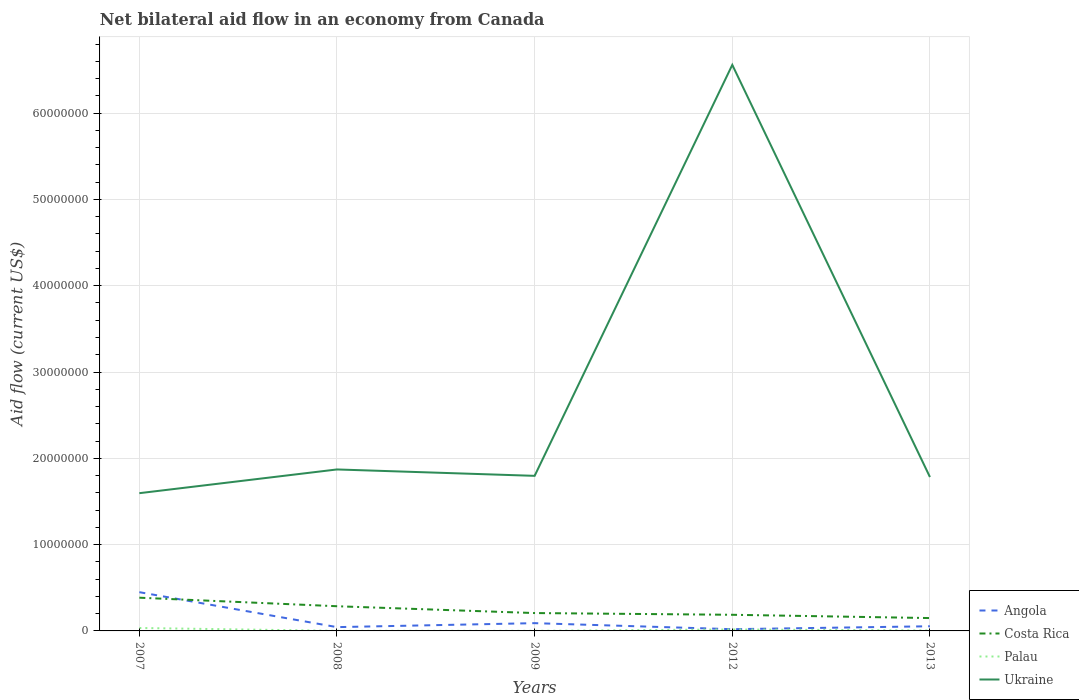Does the line corresponding to Costa Rica intersect with the line corresponding to Palau?
Provide a short and direct response. No. Is the number of lines equal to the number of legend labels?
Your answer should be compact. Yes. Across all years, what is the maximum net bilateral aid flow in Palau?
Your answer should be compact. 10000. What is the total net bilateral aid flow in Palau in the graph?
Provide a succinct answer. -1.60e+05. What is the difference between the highest and the second highest net bilateral aid flow in Palau?
Provide a short and direct response. 3.30e+05. Is the net bilateral aid flow in Ukraine strictly greater than the net bilateral aid flow in Costa Rica over the years?
Offer a very short reply. No. Are the values on the major ticks of Y-axis written in scientific E-notation?
Keep it short and to the point. No. Does the graph contain any zero values?
Your answer should be compact. No. Where does the legend appear in the graph?
Offer a very short reply. Bottom right. How many legend labels are there?
Your answer should be compact. 4. How are the legend labels stacked?
Your answer should be compact. Vertical. What is the title of the graph?
Make the answer very short. Net bilateral aid flow in an economy from Canada. What is the Aid flow (current US$) of Angola in 2007?
Your answer should be compact. 4.49e+06. What is the Aid flow (current US$) of Costa Rica in 2007?
Your response must be concise. 3.85e+06. What is the Aid flow (current US$) of Palau in 2007?
Make the answer very short. 3.40e+05. What is the Aid flow (current US$) of Ukraine in 2007?
Your answer should be very brief. 1.60e+07. What is the Aid flow (current US$) in Angola in 2008?
Your answer should be compact. 4.40e+05. What is the Aid flow (current US$) in Costa Rica in 2008?
Give a very brief answer. 2.86e+06. What is the Aid flow (current US$) in Ukraine in 2008?
Offer a terse response. 1.87e+07. What is the Aid flow (current US$) of Angola in 2009?
Ensure brevity in your answer.  9.00e+05. What is the Aid flow (current US$) of Costa Rica in 2009?
Make the answer very short. 2.07e+06. What is the Aid flow (current US$) in Ukraine in 2009?
Offer a terse response. 1.80e+07. What is the Aid flow (current US$) of Angola in 2012?
Provide a succinct answer. 2.00e+05. What is the Aid flow (current US$) in Costa Rica in 2012?
Keep it short and to the point. 1.87e+06. What is the Aid flow (current US$) in Palau in 2012?
Make the answer very short. 1.70e+05. What is the Aid flow (current US$) of Ukraine in 2012?
Your answer should be very brief. 6.56e+07. What is the Aid flow (current US$) of Angola in 2013?
Provide a succinct answer. 5.40e+05. What is the Aid flow (current US$) in Costa Rica in 2013?
Give a very brief answer. 1.49e+06. What is the Aid flow (current US$) of Palau in 2013?
Give a very brief answer. 5.00e+04. What is the Aid flow (current US$) in Ukraine in 2013?
Give a very brief answer. 1.78e+07. Across all years, what is the maximum Aid flow (current US$) of Angola?
Offer a very short reply. 4.49e+06. Across all years, what is the maximum Aid flow (current US$) of Costa Rica?
Make the answer very short. 3.85e+06. Across all years, what is the maximum Aid flow (current US$) in Ukraine?
Keep it short and to the point. 6.56e+07. Across all years, what is the minimum Aid flow (current US$) in Angola?
Provide a short and direct response. 2.00e+05. Across all years, what is the minimum Aid flow (current US$) of Costa Rica?
Provide a succinct answer. 1.49e+06. Across all years, what is the minimum Aid flow (current US$) in Palau?
Ensure brevity in your answer.  10000. Across all years, what is the minimum Aid flow (current US$) in Ukraine?
Offer a very short reply. 1.60e+07. What is the total Aid flow (current US$) of Angola in the graph?
Offer a terse response. 6.57e+06. What is the total Aid flow (current US$) of Costa Rica in the graph?
Your response must be concise. 1.21e+07. What is the total Aid flow (current US$) in Palau in the graph?
Your answer should be very brief. 5.80e+05. What is the total Aid flow (current US$) of Ukraine in the graph?
Provide a short and direct response. 1.36e+08. What is the difference between the Aid flow (current US$) in Angola in 2007 and that in 2008?
Make the answer very short. 4.05e+06. What is the difference between the Aid flow (current US$) in Costa Rica in 2007 and that in 2008?
Your answer should be very brief. 9.90e+05. What is the difference between the Aid flow (current US$) in Ukraine in 2007 and that in 2008?
Ensure brevity in your answer.  -2.75e+06. What is the difference between the Aid flow (current US$) in Angola in 2007 and that in 2009?
Give a very brief answer. 3.59e+06. What is the difference between the Aid flow (current US$) of Costa Rica in 2007 and that in 2009?
Keep it short and to the point. 1.78e+06. What is the difference between the Aid flow (current US$) in Ukraine in 2007 and that in 2009?
Your answer should be compact. -2.01e+06. What is the difference between the Aid flow (current US$) in Angola in 2007 and that in 2012?
Provide a succinct answer. 4.29e+06. What is the difference between the Aid flow (current US$) of Costa Rica in 2007 and that in 2012?
Your answer should be very brief. 1.98e+06. What is the difference between the Aid flow (current US$) of Ukraine in 2007 and that in 2012?
Make the answer very short. -4.96e+07. What is the difference between the Aid flow (current US$) in Angola in 2007 and that in 2013?
Your response must be concise. 3.95e+06. What is the difference between the Aid flow (current US$) of Costa Rica in 2007 and that in 2013?
Make the answer very short. 2.36e+06. What is the difference between the Aid flow (current US$) in Ukraine in 2007 and that in 2013?
Your response must be concise. -1.87e+06. What is the difference between the Aid flow (current US$) in Angola in 2008 and that in 2009?
Provide a succinct answer. -4.60e+05. What is the difference between the Aid flow (current US$) in Costa Rica in 2008 and that in 2009?
Keep it short and to the point. 7.90e+05. What is the difference between the Aid flow (current US$) of Palau in 2008 and that in 2009?
Ensure brevity in your answer.  0. What is the difference between the Aid flow (current US$) in Ukraine in 2008 and that in 2009?
Provide a succinct answer. 7.40e+05. What is the difference between the Aid flow (current US$) in Costa Rica in 2008 and that in 2012?
Ensure brevity in your answer.  9.90e+05. What is the difference between the Aid flow (current US$) in Palau in 2008 and that in 2012?
Make the answer very short. -1.60e+05. What is the difference between the Aid flow (current US$) of Ukraine in 2008 and that in 2012?
Your answer should be compact. -4.69e+07. What is the difference between the Aid flow (current US$) in Angola in 2008 and that in 2013?
Your response must be concise. -1.00e+05. What is the difference between the Aid flow (current US$) of Costa Rica in 2008 and that in 2013?
Offer a very short reply. 1.37e+06. What is the difference between the Aid flow (current US$) of Palau in 2008 and that in 2013?
Provide a short and direct response. -4.00e+04. What is the difference between the Aid flow (current US$) of Ukraine in 2008 and that in 2013?
Your answer should be very brief. 8.80e+05. What is the difference between the Aid flow (current US$) of Costa Rica in 2009 and that in 2012?
Provide a short and direct response. 2.00e+05. What is the difference between the Aid flow (current US$) of Ukraine in 2009 and that in 2012?
Provide a succinct answer. -4.76e+07. What is the difference between the Aid flow (current US$) in Angola in 2009 and that in 2013?
Your response must be concise. 3.60e+05. What is the difference between the Aid flow (current US$) of Costa Rica in 2009 and that in 2013?
Your response must be concise. 5.80e+05. What is the difference between the Aid flow (current US$) of Ukraine in 2009 and that in 2013?
Your response must be concise. 1.40e+05. What is the difference between the Aid flow (current US$) in Angola in 2012 and that in 2013?
Ensure brevity in your answer.  -3.40e+05. What is the difference between the Aid flow (current US$) of Ukraine in 2012 and that in 2013?
Offer a very short reply. 4.78e+07. What is the difference between the Aid flow (current US$) in Angola in 2007 and the Aid flow (current US$) in Costa Rica in 2008?
Keep it short and to the point. 1.63e+06. What is the difference between the Aid flow (current US$) of Angola in 2007 and the Aid flow (current US$) of Palau in 2008?
Offer a terse response. 4.48e+06. What is the difference between the Aid flow (current US$) in Angola in 2007 and the Aid flow (current US$) in Ukraine in 2008?
Your response must be concise. -1.42e+07. What is the difference between the Aid flow (current US$) in Costa Rica in 2007 and the Aid flow (current US$) in Palau in 2008?
Your answer should be compact. 3.84e+06. What is the difference between the Aid flow (current US$) of Costa Rica in 2007 and the Aid flow (current US$) of Ukraine in 2008?
Give a very brief answer. -1.49e+07. What is the difference between the Aid flow (current US$) of Palau in 2007 and the Aid flow (current US$) of Ukraine in 2008?
Offer a terse response. -1.84e+07. What is the difference between the Aid flow (current US$) of Angola in 2007 and the Aid flow (current US$) of Costa Rica in 2009?
Provide a succinct answer. 2.42e+06. What is the difference between the Aid flow (current US$) in Angola in 2007 and the Aid flow (current US$) in Palau in 2009?
Offer a terse response. 4.48e+06. What is the difference between the Aid flow (current US$) in Angola in 2007 and the Aid flow (current US$) in Ukraine in 2009?
Keep it short and to the point. -1.35e+07. What is the difference between the Aid flow (current US$) of Costa Rica in 2007 and the Aid flow (current US$) of Palau in 2009?
Keep it short and to the point. 3.84e+06. What is the difference between the Aid flow (current US$) of Costa Rica in 2007 and the Aid flow (current US$) of Ukraine in 2009?
Provide a succinct answer. -1.41e+07. What is the difference between the Aid flow (current US$) in Palau in 2007 and the Aid flow (current US$) in Ukraine in 2009?
Give a very brief answer. -1.76e+07. What is the difference between the Aid flow (current US$) of Angola in 2007 and the Aid flow (current US$) of Costa Rica in 2012?
Give a very brief answer. 2.62e+06. What is the difference between the Aid flow (current US$) in Angola in 2007 and the Aid flow (current US$) in Palau in 2012?
Make the answer very short. 4.32e+06. What is the difference between the Aid flow (current US$) of Angola in 2007 and the Aid flow (current US$) of Ukraine in 2012?
Keep it short and to the point. -6.11e+07. What is the difference between the Aid flow (current US$) in Costa Rica in 2007 and the Aid flow (current US$) in Palau in 2012?
Offer a terse response. 3.68e+06. What is the difference between the Aid flow (current US$) of Costa Rica in 2007 and the Aid flow (current US$) of Ukraine in 2012?
Keep it short and to the point. -6.17e+07. What is the difference between the Aid flow (current US$) of Palau in 2007 and the Aid flow (current US$) of Ukraine in 2012?
Make the answer very short. -6.52e+07. What is the difference between the Aid flow (current US$) of Angola in 2007 and the Aid flow (current US$) of Costa Rica in 2013?
Your response must be concise. 3.00e+06. What is the difference between the Aid flow (current US$) in Angola in 2007 and the Aid flow (current US$) in Palau in 2013?
Offer a very short reply. 4.44e+06. What is the difference between the Aid flow (current US$) of Angola in 2007 and the Aid flow (current US$) of Ukraine in 2013?
Offer a very short reply. -1.33e+07. What is the difference between the Aid flow (current US$) in Costa Rica in 2007 and the Aid flow (current US$) in Palau in 2013?
Your answer should be compact. 3.80e+06. What is the difference between the Aid flow (current US$) of Costa Rica in 2007 and the Aid flow (current US$) of Ukraine in 2013?
Provide a succinct answer. -1.40e+07. What is the difference between the Aid flow (current US$) of Palau in 2007 and the Aid flow (current US$) of Ukraine in 2013?
Your response must be concise. -1.75e+07. What is the difference between the Aid flow (current US$) of Angola in 2008 and the Aid flow (current US$) of Costa Rica in 2009?
Offer a very short reply. -1.63e+06. What is the difference between the Aid flow (current US$) of Angola in 2008 and the Aid flow (current US$) of Palau in 2009?
Offer a terse response. 4.30e+05. What is the difference between the Aid flow (current US$) in Angola in 2008 and the Aid flow (current US$) in Ukraine in 2009?
Offer a terse response. -1.75e+07. What is the difference between the Aid flow (current US$) in Costa Rica in 2008 and the Aid flow (current US$) in Palau in 2009?
Ensure brevity in your answer.  2.85e+06. What is the difference between the Aid flow (current US$) in Costa Rica in 2008 and the Aid flow (current US$) in Ukraine in 2009?
Your answer should be compact. -1.51e+07. What is the difference between the Aid flow (current US$) of Palau in 2008 and the Aid flow (current US$) of Ukraine in 2009?
Your answer should be very brief. -1.80e+07. What is the difference between the Aid flow (current US$) of Angola in 2008 and the Aid flow (current US$) of Costa Rica in 2012?
Provide a short and direct response. -1.43e+06. What is the difference between the Aid flow (current US$) of Angola in 2008 and the Aid flow (current US$) of Palau in 2012?
Keep it short and to the point. 2.70e+05. What is the difference between the Aid flow (current US$) of Angola in 2008 and the Aid flow (current US$) of Ukraine in 2012?
Keep it short and to the point. -6.52e+07. What is the difference between the Aid flow (current US$) of Costa Rica in 2008 and the Aid flow (current US$) of Palau in 2012?
Ensure brevity in your answer.  2.69e+06. What is the difference between the Aid flow (current US$) in Costa Rica in 2008 and the Aid flow (current US$) in Ukraine in 2012?
Your response must be concise. -6.27e+07. What is the difference between the Aid flow (current US$) in Palau in 2008 and the Aid flow (current US$) in Ukraine in 2012?
Provide a short and direct response. -6.56e+07. What is the difference between the Aid flow (current US$) in Angola in 2008 and the Aid flow (current US$) in Costa Rica in 2013?
Offer a terse response. -1.05e+06. What is the difference between the Aid flow (current US$) of Angola in 2008 and the Aid flow (current US$) of Ukraine in 2013?
Your response must be concise. -1.74e+07. What is the difference between the Aid flow (current US$) in Costa Rica in 2008 and the Aid flow (current US$) in Palau in 2013?
Your answer should be compact. 2.81e+06. What is the difference between the Aid flow (current US$) of Costa Rica in 2008 and the Aid flow (current US$) of Ukraine in 2013?
Provide a short and direct response. -1.50e+07. What is the difference between the Aid flow (current US$) of Palau in 2008 and the Aid flow (current US$) of Ukraine in 2013?
Your response must be concise. -1.78e+07. What is the difference between the Aid flow (current US$) of Angola in 2009 and the Aid flow (current US$) of Costa Rica in 2012?
Provide a short and direct response. -9.70e+05. What is the difference between the Aid flow (current US$) in Angola in 2009 and the Aid flow (current US$) in Palau in 2012?
Ensure brevity in your answer.  7.30e+05. What is the difference between the Aid flow (current US$) in Angola in 2009 and the Aid flow (current US$) in Ukraine in 2012?
Offer a terse response. -6.47e+07. What is the difference between the Aid flow (current US$) of Costa Rica in 2009 and the Aid flow (current US$) of Palau in 2012?
Offer a very short reply. 1.90e+06. What is the difference between the Aid flow (current US$) of Costa Rica in 2009 and the Aid flow (current US$) of Ukraine in 2012?
Your answer should be compact. -6.35e+07. What is the difference between the Aid flow (current US$) of Palau in 2009 and the Aid flow (current US$) of Ukraine in 2012?
Give a very brief answer. -6.56e+07. What is the difference between the Aid flow (current US$) of Angola in 2009 and the Aid flow (current US$) of Costa Rica in 2013?
Make the answer very short. -5.90e+05. What is the difference between the Aid flow (current US$) in Angola in 2009 and the Aid flow (current US$) in Palau in 2013?
Provide a short and direct response. 8.50e+05. What is the difference between the Aid flow (current US$) of Angola in 2009 and the Aid flow (current US$) of Ukraine in 2013?
Your answer should be very brief. -1.69e+07. What is the difference between the Aid flow (current US$) in Costa Rica in 2009 and the Aid flow (current US$) in Palau in 2013?
Your answer should be compact. 2.02e+06. What is the difference between the Aid flow (current US$) of Costa Rica in 2009 and the Aid flow (current US$) of Ukraine in 2013?
Keep it short and to the point. -1.58e+07. What is the difference between the Aid flow (current US$) in Palau in 2009 and the Aid flow (current US$) in Ukraine in 2013?
Provide a succinct answer. -1.78e+07. What is the difference between the Aid flow (current US$) in Angola in 2012 and the Aid flow (current US$) in Costa Rica in 2013?
Your answer should be very brief. -1.29e+06. What is the difference between the Aid flow (current US$) of Angola in 2012 and the Aid flow (current US$) of Palau in 2013?
Your response must be concise. 1.50e+05. What is the difference between the Aid flow (current US$) of Angola in 2012 and the Aid flow (current US$) of Ukraine in 2013?
Your answer should be compact. -1.76e+07. What is the difference between the Aid flow (current US$) of Costa Rica in 2012 and the Aid flow (current US$) of Palau in 2013?
Offer a terse response. 1.82e+06. What is the difference between the Aid flow (current US$) of Costa Rica in 2012 and the Aid flow (current US$) of Ukraine in 2013?
Ensure brevity in your answer.  -1.60e+07. What is the difference between the Aid flow (current US$) in Palau in 2012 and the Aid flow (current US$) in Ukraine in 2013?
Provide a short and direct response. -1.77e+07. What is the average Aid flow (current US$) in Angola per year?
Make the answer very short. 1.31e+06. What is the average Aid flow (current US$) of Costa Rica per year?
Make the answer very short. 2.43e+06. What is the average Aid flow (current US$) of Palau per year?
Keep it short and to the point. 1.16e+05. What is the average Aid flow (current US$) in Ukraine per year?
Your response must be concise. 2.72e+07. In the year 2007, what is the difference between the Aid flow (current US$) of Angola and Aid flow (current US$) of Costa Rica?
Make the answer very short. 6.40e+05. In the year 2007, what is the difference between the Aid flow (current US$) of Angola and Aid flow (current US$) of Palau?
Offer a terse response. 4.15e+06. In the year 2007, what is the difference between the Aid flow (current US$) in Angola and Aid flow (current US$) in Ukraine?
Provide a succinct answer. -1.15e+07. In the year 2007, what is the difference between the Aid flow (current US$) of Costa Rica and Aid flow (current US$) of Palau?
Ensure brevity in your answer.  3.51e+06. In the year 2007, what is the difference between the Aid flow (current US$) of Costa Rica and Aid flow (current US$) of Ukraine?
Your response must be concise. -1.21e+07. In the year 2007, what is the difference between the Aid flow (current US$) of Palau and Aid flow (current US$) of Ukraine?
Your response must be concise. -1.56e+07. In the year 2008, what is the difference between the Aid flow (current US$) in Angola and Aid flow (current US$) in Costa Rica?
Give a very brief answer. -2.42e+06. In the year 2008, what is the difference between the Aid flow (current US$) in Angola and Aid flow (current US$) in Ukraine?
Your response must be concise. -1.83e+07. In the year 2008, what is the difference between the Aid flow (current US$) in Costa Rica and Aid flow (current US$) in Palau?
Provide a short and direct response. 2.85e+06. In the year 2008, what is the difference between the Aid flow (current US$) in Costa Rica and Aid flow (current US$) in Ukraine?
Ensure brevity in your answer.  -1.58e+07. In the year 2008, what is the difference between the Aid flow (current US$) in Palau and Aid flow (current US$) in Ukraine?
Ensure brevity in your answer.  -1.87e+07. In the year 2009, what is the difference between the Aid flow (current US$) of Angola and Aid flow (current US$) of Costa Rica?
Keep it short and to the point. -1.17e+06. In the year 2009, what is the difference between the Aid flow (current US$) in Angola and Aid flow (current US$) in Palau?
Keep it short and to the point. 8.90e+05. In the year 2009, what is the difference between the Aid flow (current US$) in Angola and Aid flow (current US$) in Ukraine?
Provide a short and direct response. -1.71e+07. In the year 2009, what is the difference between the Aid flow (current US$) in Costa Rica and Aid flow (current US$) in Palau?
Keep it short and to the point. 2.06e+06. In the year 2009, what is the difference between the Aid flow (current US$) in Costa Rica and Aid flow (current US$) in Ukraine?
Provide a short and direct response. -1.59e+07. In the year 2009, what is the difference between the Aid flow (current US$) in Palau and Aid flow (current US$) in Ukraine?
Offer a terse response. -1.80e+07. In the year 2012, what is the difference between the Aid flow (current US$) of Angola and Aid flow (current US$) of Costa Rica?
Your response must be concise. -1.67e+06. In the year 2012, what is the difference between the Aid flow (current US$) in Angola and Aid flow (current US$) in Palau?
Your answer should be compact. 3.00e+04. In the year 2012, what is the difference between the Aid flow (current US$) of Angola and Aid flow (current US$) of Ukraine?
Provide a short and direct response. -6.54e+07. In the year 2012, what is the difference between the Aid flow (current US$) in Costa Rica and Aid flow (current US$) in Palau?
Your answer should be compact. 1.70e+06. In the year 2012, what is the difference between the Aid flow (current US$) in Costa Rica and Aid flow (current US$) in Ukraine?
Offer a very short reply. -6.37e+07. In the year 2012, what is the difference between the Aid flow (current US$) of Palau and Aid flow (current US$) of Ukraine?
Keep it short and to the point. -6.54e+07. In the year 2013, what is the difference between the Aid flow (current US$) in Angola and Aid flow (current US$) in Costa Rica?
Ensure brevity in your answer.  -9.50e+05. In the year 2013, what is the difference between the Aid flow (current US$) in Angola and Aid flow (current US$) in Palau?
Keep it short and to the point. 4.90e+05. In the year 2013, what is the difference between the Aid flow (current US$) in Angola and Aid flow (current US$) in Ukraine?
Provide a succinct answer. -1.73e+07. In the year 2013, what is the difference between the Aid flow (current US$) in Costa Rica and Aid flow (current US$) in Palau?
Make the answer very short. 1.44e+06. In the year 2013, what is the difference between the Aid flow (current US$) in Costa Rica and Aid flow (current US$) in Ukraine?
Keep it short and to the point. -1.63e+07. In the year 2013, what is the difference between the Aid flow (current US$) in Palau and Aid flow (current US$) in Ukraine?
Your answer should be very brief. -1.78e+07. What is the ratio of the Aid flow (current US$) of Angola in 2007 to that in 2008?
Give a very brief answer. 10.2. What is the ratio of the Aid flow (current US$) in Costa Rica in 2007 to that in 2008?
Give a very brief answer. 1.35. What is the ratio of the Aid flow (current US$) in Palau in 2007 to that in 2008?
Offer a very short reply. 34. What is the ratio of the Aid flow (current US$) in Ukraine in 2007 to that in 2008?
Offer a very short reply. 0.85. What is the ratio of the Aid flow (current US$) of Angola in 2007 to that in 2009?
Your answer should be very brief. 4.99. What is the ratio of the Aid flow (current US$) of Costa Rica in 2007 to that in 2009?
Your answer should be very brief. 1.86. What is the ratio of the Aid flow (current US$) of Palau in 2007 to that in 2009?
Your answer should be compact. 34. What is the ratio of the Aid flow (current US$) in Ukraine in 2007 to that in 2009?
Your answer should be compact. 0.89. What is the ratio of the Aid flow (current US$) of Angola in 2007 to that in 2012?
Offer a terse response. 22.45. What is the ratio of the Aid flow (current US$) of Costa Rica in 2007 to that in 2012?
Give a very brief answer. 2.06. What is the ratio of the Aid flow (current US$) in Ukraine in 2007 to that in 2012?
Your response must be concise. 0.24. What is the ratio of the Aid flow (current US$) of Angola in 2007 to that in 2013?
Your answer should be very brief. 8.31. What is the ratio of the Aid flow (current US$) in Costa Rica in 2007 to that in 2013?
Provide a succinct answer. 2.58. What is the ratio of the Aid flow (current US$) in Ukraine in 2007 to that in 2013?
Your response must be concise. 0.9. What is the ratio of the Aid flow (current US$) in Angola in 2008 to that in 2009?
Provide a short and direct response. 0.49. What is the ratio of the Aid flow (current US$) in Costa Rica in 2008 to that in 2009?
Offer a terse response. 1.38. What is the ratio of the Aid flow (current US$) in Palau in 2008 to that in 2009?
Your answer should be very brief. 1. What is the ratio of the Aid flow (current US$) in Ukraine in 2008 to that in 2009?
Your answer should be very brief. 1.04. What is the ratio of the Aid flow (current US$) of Angola in 2008 to that in 2012?
Give a very brief answer. 2.2. What is the ratio of the Aid flow (current US$) in Costa Rica in 2008 to that in 2012?
Keep it short and to the point. 1.53. What is the ratio of the Aid flow (current US$) of Palau in 2008 to that in 2012?
Your answer should be very brief. 0.06. What is the ratio of the Aid flow (current US$) in Ukraine in 2008 to that in 2012?
Your response must be concise. 0.29. What is the ratio of the Aid flow (current US$) of Angola in 2008 to that in 2013?
Your response must be concise. 0.81. What is the ratio of the Aid flow (current US$) in Costa Rica in 2008 to that in 2013?
Keep it short and to the point. 1.92. What is the ratio of the Aid flow (current US$) in Ukraine in 2008 to that in 2013?
Your response must be concise. 1.05. What is the ratio of the Aid flow (current US$) in Angola in 2009 to that in 2012?
Ensure brevity in your answer.  4.5. What is the ratio of the Aid flow (current US$) in Costa Rica in 2009 to that in 2012?
Your response must be concise. 1.11. What is the ratio of the Aid flow (current US$) of Palau in 2009 to that in 2012?
Make the answer very short. 0.06. What is the ratio of the Aid flow (current US$) in Ukraine in 2009 to that in 2012?
Provide a succinct answer. 0.27. What is the ratio of the Aid flow (current US$) of Angola in 2009 to that in 2013?
Give a very brief answer. 1.67. What is the ratio of the Aid flow (current US$) of Costa Rica in 2009 to that in 2013?
Your answer should be very brief. 1.39. What is the ratio of the Aid flow (current US$) in Ukraine in 2009 to that in 2013?
Provide a succinct answer. 1.01. What is the ratio of the Aid flow (current US$) in Angola in 2012 to that in 2013?
Provide a short and direct response. 0.37. What is the ratio of the Aid flow (current US$) in Costa Rica in 2012 to that in 2013?
Your answer should be very brief. 1.25. What is the ratio of the Aid flow (current US$) of Palau in 2012 to that in 2013?
Make the answer very short. 3.4. What is the ratio of the Aid flow (current US$) in Ukraine in 2012 to that in 2013?
Your response must be concise. 3.68. What is the difference between the highest and the second highest Aid flow (current US$) in Angola?
Provide a short and direct response. 3.59e+06. What is the difference between the highest and the second highest Aid flow (current US$) in Costa Rica?
Your answer should be very brief. 9.90e+05. What is the difference between the highest and the second highest Aid flow (current US$) in Palau?
Offer a terse response. 1.70e+05. What is the difference between the highest and the second highest Aid flow (current US$) of Ukraine?
Ensure brevity in your answer.  4.69e+07. What is the difference between the highest and the lowest Aid flow (current US$) in Angola?
Your response must be concise. 4.29e+06. What is the difference between the highest and the lowest Aid flow (current US$) in Costa Rica?
Keep it short and to the point. 2.36e+06. What is the difference between the highest and the lowest Aid flow (current US$) of Ukraine?
Your answer should be compact. 4.96e+07. 